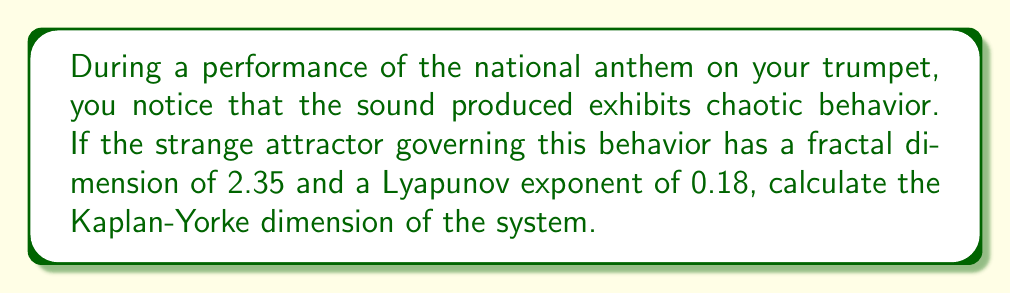Could you help me with this problem? To solve this problem, we'll follow these steps:

1) The Kaplan-Yorke dimension, also known as the Lyapunov dimension, is a measure of the complexity of a strange attractor. It's calculated using the formula:

   $$D_{KY} = j + \frac{\sum_{i=1}^j \lambda_i}{|\lambda_{j+1}|}$$

   where $j$ is the largest integer such that $\sum_{i=1}^j \lambda_i \geq 0$, and $\lambda_i$ are the Lyapunov exponents in descending order.

2) We're given that the fractal dimension is 2.35. In many cases, the fractal dimension is approximately equal to the Kaplan-Yorke dimension. So we can estimate that $D_{KY} \approx 2.35$.

3) We're also given one Lyapunov exponent, $\lambda_1 = 0.18$. For a system with a Kaplan-Yorke dimension between 2 and 3, we need at least three Lyapunov exponents.

4) Let's call the unknown exponents $\lambda_2$ and $\lambda_3$. We know that $\lambda_1 + \lambda_2 \geq 0$ and $\lambda_1 + \lambda_2 + \lambda_3 < 0$.

5) Using the Kaplan-Yorke dimension formula:

   $$2.35 \approx 2 + \frac{\lambda_1 + \lambda_2}{|\lambda_3|}$$

6) Rearranging this equation:

   $$0.35 |\lambda_3| \approx \lambda_1 + \lambda_2$$

7) We know $\lambda_1 = 0.18$, so:

   $$0.35 |\lambda_3| \approx 0.18 + \lambda_2$$

8) This equation has multiple solutions, but a common scenario in chaotic systems is where $\lambda_2 \approx 0$. If we assume this:

   $$0.35 |\lambda_3| \approx 0.18$$
   $$|\lambda_3| \approx 0.514$$

9) The negative sign for $\lambda_3$ ensures that $\lambda_1 + \lambda_2 + \lambda_3 < 0$:

   $$\lambda_3 \approx -0.514$$

Therefore, a set of Lyapunov exponents consistent with the given information is approximately:
$\lambda_1 = 0.18$, $\lambda_2 = 0$, $\lambda_3 = -0.514$
Answer: $\lambda_1 \approx 0.18$, $\lambda_2 \approx 0$, $\lambda_3 \approx -0.514$ 